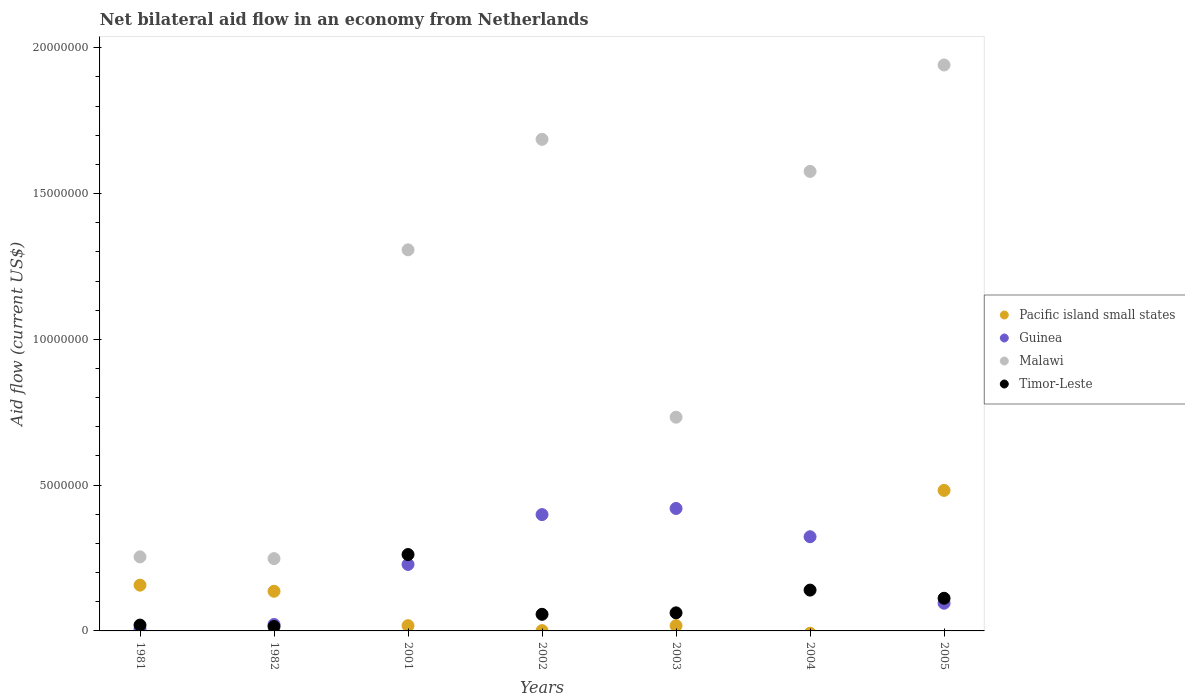How many different coloured dotlines are there?
Your response must be concise. 4. What is the net bilateral aid flow in Malawi in 2005?
Ensure brevity in your answer.  1.94e+07. Across all years, what is the maximum net bilateral aid flow in Timor-Leste?
Keep it short and to the point. 2.62e+06. What is the total net bilateral aid flow in Malawi in the graph?
Keep it short and to the point. 7.74e+07. What is the difference between the net bilateral aid flow in Timor-Leste in 1981 and that in 2004?
Give a very brief answer. -1.20e+06. What is the average net bilateral aid flow in Pacific island small states per year?
Make the answer very short. 1.16e+06. In the year 2003, what is the difference between the net bilateral aid flow in Malawi and net bilateral aid flow in Pacific island small states?
Your answer should be compact. 7.15e+06. What is the ratio of the net bilateral aid flow in Guinea in 1981 to that in 2005?
Your answer should be compact. 0.07. Is the net bilateral aid flow in Guinea in 2003 less than that in 2004?
Your answer should be very brief. No. What is the difference between the highest and the second highest net bilateral aid flow in Timor-Leste?
Provide a succinct answer. 1.22e+06. What is the difference between the highest and the lowest net bilateral aid flow in Pacific island small states?
Your answer should be compact. 4.82e+06. In how many years, is the net bilateral aid flow in Pacific island small states greater than the average net bilateral aid flow in Pacific island small states taken over all years?
Keep it short and to the point. 3. Is the sum of the net bilateral aid flow in Pacific island small states in 2001 and 2005 greater than the maximum net bilateral aid flow in Guinea across all years?
Provide a short and direct response. Yes. Does the net bilateral aid flow in Guinea monotonically increase over the years?
Give a very brief answer. No. Is the net bilateral aid flow in Malawi strictly greater than the net bilateral aid flow in Guinea over the years?
Make the answer very short. Yes. Is the net bilateral aid flow in Pacific island small states strictly less than the net bilateral aid flow in Malawi over the years?
Your answer should be very brief. Yes. How many years are there in the graph?
Offer a very short reply. 7. Are the values on the major ticks of Y-axis written in scientific E-notation?
Your answer should be compact. No. Does the graph contain grids?
Your answer should be compact. No. Where does the legend appear in the graph?
Offer a very short reply. Center right. What is the title of the graph?
Your answer should be very brief. Net bilateral aid flow in an economy from Netherlands. What is the Aid flow (current US$) in Pacific island small states in 1981?
Your response must be concise. 1.57e+06. What is the Aid flow (current US$) of Malawi in 1981?
Your answer should be compact. 2.54e+06. What is the Aid flow (current US$) of Timor-Leste in 1981?
Keep it short and to the point. 2.00e+05. What is the Aid flow (current US$) in Pacific island small states in 1982?
Offer a very short reply. 1.36e+06. What is the Aid flow (current US$) of Malawi in 1982?
Your answer should be compact. 2.48e+06. What is the Aid flow (current US$) in Timor-Leste in 1982?
Ensure brevity in your answer.  1.50e+05. What is the Aid flow (current US$) of Guinea in 2001?
Your response must be concise. 2.28e+06. What is the Aid flow (current US$) in Malawi in 2001?
Offer a very short reply. 1.31e+07. What is the Aid flow (current US$) in Timor-Leste in 2001?
Make the answer very short. 2.62e+06. What is the Aid flow (current US$) of Pacific island small states in 2002?
Your answer should be compact. 10000. What is the Aid flow (current US$) of Guinea in 2002?
Give a very brief answer. 3.99e+06. What is the Aid flow (current US$) in Malawi in 2002?
Give a very brief answer. 1.69e+07. What is the Aid flow (current US$) of Timor-Leste in 2002?
Offer a terse response. 5.70e+05. What is the Aid flow (current US$) of Pacific island small states in 2003?
Provide a short and direct response. 1.80e+05. What is the Aid flow (current US$) of Guinea in 2003?
Your response must be concise. 4.20e+06. What is the Aid flow (current US$) of Malawi in 2003?
Offer a very short reply. 7.33e+06. What is the Aid flow (current US$) of Timor-Leste in 2003?
Your answer should be very brief. 6.20e+05. What is the Aid flow (current US$) in Pacific island small states in 2004?
Keep it short and to the point. 0. What is the Aid flow (current US$) of Guinea in 2004?
Ensure brevity in your answer.  3.23e+06. What is the Aid flow (current US$) in Malawi in 2004?
Provide a short and direct response. 1.58e+07. What is the Aid flow (current US$) of Timor-Leste in 2004?
Keep it short and to the point. 1.40e+06. What is the Aid flow (current US$) in Pacific island small states in 2005?
Offer a very short reply. 4.82e+06. What is the Aid flow (current US$) of Guinea in 2005?
Your response must be concise. 9.50e+05. What is the Aid flow (current US$) in Malawi in 2005?
Ensure brevity in your answer.  1.94e+07. What is the Aid flow (current US$) in Timor-Leste in 2005?
Provide a short and direct response. 1.12e+06. Across all years, what is the maximum Aid flow (current US$) of Pacific island small states?
Offer a very short reply. 4.82e+06. Across all years, what is the maximum Aid flow (current US$) of Guinea?
Provide a succinct answer. 4.20e+06. Across all years, what is the maximum Aid flow (current US$) in Malawi?
Provide a succinct answer. 1.94e+07. Across all years, what is the maximum Aid flow (current US$) in Timor-Leste?
Make the answer very short. 2.62e+06. Across all years, what is the minimum Aid flow (current US$) of Pacific island small states?
Keep it short and to the point. 0. Across all years, what is the minimum Aid flow (current US$) in Malawi?
Your answer should be very brief. 2.48e+06. What is the total Aid flow (current US$) in Pacific island small states in the graph?
Your response must be concise. 8.12e+06. What is the total Aid flow (current US$) of Guinea in the graph?
Make the answer very short. 1.49e+07. What is the total Aid flow (current US$) of Malawi in the graph?
Provide a succinct answer. 7.74e+07. What is the total Aid flow (current US$) in Timor-Leste in the graph?
Make the answer very short. 6.68e+06. What is the difference between the Aid flow (current US$) in Pacific island small states in 1981 and that in 1982?
Your answer should be very brief. 2.10e+05. What is the difference between the Aid flow (current US$) of Guinea in 1981 and that in 1982?
Your answer should be very brief. -1.50e+05. What is the difference between the Aid flow (current US$) of Pacific island small states in 1981 and that in 2001?
Your answer should be very brief. 1.39e+06. What is the difference between the Aid flow (current US$) of Guinea in 1981 and that in 2001?
Provide a short and direct response. -2.21e+06. What is the difference between the Aid flow (current US$) in Malawi in 1981 and that in 2001?
Keep it short and to the point. -1.05e+07. What is the difference between the Aid flow (current US$) in Timor-Leste in 1981 and that in 2001?
Provide a succinct answer. -2.42e+06. What is the difference between the Aid flow (current US$) in Pacific island small states in 1981 and that in 2002?
Keep it short and to the point. 1.56e+06. What is the difference between the Aid flow (current US$) in Guinea in 1981 and that in 2002?
Give a very brief answer. -3.92e+06. What is the difference between the Aid flow (current US$) in Malawi in 1981 and that in 2002?
Give a very brief answer. -1.43e+07. What is the difference between the Aid flow (current US$) in Timor-Leste in 1981 and that in 2002?
Keep it short and to the point. -3.70e+05. What is the difference between the Aid flow (current US$) in Pacific island small states in 1981 and that in 2003?
Offer a very short reply. 1.39e+06. What is the difference between the Aid flow (current US$) in Guinea in 1981 and that in 2003?
Ensure brevity in your answer.  -4.13e+06. What is the difference between the Aid flow (current US$) of Malawi in 1981 and that in 2003?
Give a very brief answer. -4.79e+06. What is the difference between the Aid flow (current US$) of Timor-Leste in 1981 and that in 2003?
Keep it short and to the point. -4.20e+05. What is the difference between the Aid flow (current US$) in Guinea in 1981 and that in 2004?
Offer a terse response. -3.16e+06. What is the difference between the Aid flow (current US$) in Malawi in 1981 and that in 2004?
Make the answer very short. -1.32e+07. What is the difference between the Aid flow (current US$) of Timor-Leste in 1981 and that in 2004?
Offer a very short reply. -1.20e+06. What is the difference between the Aid flow (current US$) in Pacific island small states in 1981 and that in 2005?
Provide a short and direct response. -3.25e+06. What is the difference between the Aid flow (current US$) of Guinea in 1981 and that in 2005?
Offer a very short reply. -8.80e+05. What is the difference between the Aid flow (current US$) of Malawi in 1981 and that in 2005?
Ensure brevity in your answer.  -1.69e+07. What is the difference between the Aid flow (current US$) in Timor-Leste in 1981 and that in 2005?
Provide a short and direct response. -9.20e+05. What is the difference between the Aid flow (current US$) of Pacific island small states in 1982 and that in 2001?
Your answer should be very brief. 1.18e+06. What is the difference between the Aid flow (current US$) of Guinea in 1982 and that in 2001?
Provide a short and direct response. -2.06e+06. What is the difference between the Aid flow (current US$) in Malawi in 1982 and that in 2001?
Your answer should be compact. -1.06e+07. What is the difference between the Aid flow (current US$) in Timor-Leste in 1982 and that in 2001?
Provide a succinct answer. -2.47e+06. What is the difference between the Aid flow (current US$) of Pacific island small states in 1982 and that in 2002?
Give a very brief answer. 1.35e+06. What is the difference between the Aid flow (current US$) in Guinea in 1982 and that in 2002?
Your answer should be compact. -3.77e+06. What is the difference between the Aid flow (current US$) of Malawi in 1982 and that in 2002?
Your response must be concise. -1.44e+07. What is the difference between the Aid flow (current US$) of Timor-Leste in 1982 and that in 2002?
Provide a short and direct response. -4.20e+05. What is the difference between the Aid flow (current US$) in Pacific island small states in 1982 and that in 2003?
Provide a succinct answer. 1.18e+06. What is the difference between the Aid flow (current US$) in Guinea in 1982 and that in 2003?
Offer a very short reply. -3.98e+06. What is the difference between the Aid flow (current US$) of Malawi in 1982 and that in 2003?
Keep it short and to the point. -4.85e+06. What is the difference between the Aid flow (current US$) in Timor-Leste in 1982 and that in 2003?
Ensure brevity in your answer.  -4.70e+05. What is the difference between the Aid flow (current US$) in Guinea in 1982 and that in 2004?
Offer a very short reply. -3.01e+06. What is the difference between the Aid flow (current US$) of Malawi in 1982 and that in 2004?
Keep it short and to the point. -1.33e+07. What is the difference between the Aid flow (current US$) in Timor-Leste in 1982 and that in 2004?
Ensure brevity in your answer.  -1.25e+06. What is the difference between the Aid flow (current US$) in Pacific island small states in 1982 and that in 2005?
Make the answer very short. -3.46e+06. What is the difference between the Aid flow (current US$) in Guinea in 1982 and that in 2005?
Offer a very short reply. -7.30e+05. What is the difference between the Aid flow (current US$) in Malawi in 1982 and that in 2005?
Provide a short and direct response. -1.69e+07. What is the difference between the Aid flow (current US$) in Timor-Leste in 1982 and that in 2005?
Provide a succinct answer. -9.70e+05. What is the difference between the Aid flow (current US$) in Guinea in 2001 and that in 2002?
Your answer should be compact. -1.71e+06. What is the difference between the Aid flow (current US$) of Malawi in 2001 and that in 2002?
Your answer should be very brief. -3.79e+06. What is the difference between the Aid flow (current US$) in Timor-Leste in 2001 and that in 2002?
Your answer should be compact. 2.05e+06. What is the difference between the Aid flow (current US$) of Guinea in 2001 and that in 2003?
Your answer should be very brief. -1.92e+06. What is the difference between the Aid flow (current US$) in Malawi in 2001 and that in 2003?
Your response must be concise. 5.74e+06. What is the difference between the Aid flow (current US$) of Timor-Leste in 2001 and that in 2003?
Offer a terse response. 2.00e+06. What is the difference between the Aid flow (current US$) of Guinea in 2001 and that in 2004?
Keep it short and to the point. -9.50e+05. What is the difference between the Aid flow (current US$) of Malawi in 2001 and that in 2004?
Your answer should be very brief. -2.69e+06. What is the difference between the Aid flow (current US$) of Timor-Leste in 2001 and that in 2004?
Ensure brevity in your answer.  1.22e+06. What is the difference between the Aid flow (current US$) in Pacific island small states in 2001 and that in 2005?
Make the answer very short. -4.64e+06. What is the difference between the Aid flow (current US$) in Guinea in 2001 and that in 2005?
Offer a terse response. 1.33e+06. What is the difference between the Aid flow (current US$) in Malawi in 2001 and that in 2005?
Keep it short and to the point. -6.34e+06. What is the difference between the Aid flow (current US$) in Timor-Leste in 2001 and that in 2005?
Give a very brief answer. 1.50e+06. What is the difference between the Aid flow (current US$) in Pacific island small states in 2002 and that in 2003?
Offer a terse response. -1.70e+05. What is the difference between the Aid flow (current US$) of Malawi in 2002 and that in 2003?
Offer a terse response. 9.53e+06. What is the difference between the Aid flow (current US$) in Timor-Leste in 2002 and that in 2003?
Provide a succinct answer. -5.00e+04. What is the difference between the Aid flow (current US$) of Guinea in 2002 and that in 2004?
Ensure brevity in your answer.  7.60e+05. What is the difference between the Aid flow (current US$) in Malawi in 2002 and that in 2004?
Your answer should be very brief. 1.10e+06. What is the difference between the Aid flow (current US$) in Timor-Leste in 2002 and that in 2004?
Provide a short and direct response. -8.30e+05. What is the difference between the Aid flow (current US$) of Pacific island small states in 2002 and that in 2005?
Keep it short and to the point. -4.81e+06. What is the difference between the Aid flow (current US$) of Guinea in 2002 and that in 2005?
Your response must be concise. 3.04e+06. What is the difference between the Aid flow (current US$) in Malawi in 2002 and that in 2005?
Give a very brief answer. -2.55e+06. What is the difference between the Aid flow (current US$) in Timor-Leste in 2002 and that in 2005?
Your answer should be compact. -5.50e+05. What is the difference between the Aid flow (current US$) of Guinea in 2003 and that in 2004?
Offer a very short reply. 9.70e+05. What is the difference between the Aid flow (current US$) of Malawi in 2003 and that in 2004?
Provide a succinct answer. -8.43e+06. What is the difference between the Aid flow (current US$) of Timor-Leste in 2003 and that in 2004?
Offer a very short reply. -7.80e+05. What is the difference between the Aid flow (current US$) in Pacific island small states in 2003 and that in 2005?
Offer a very short reply. -4.64e+06. What is the difference between the Aid flow (current US$) of Guinea in 2003 and that in 2005?
Offer a very short reply. 3.25e+06. What is the difference between the Aid flow (current US$) of Malawi in 2003 and that in 2005?
Provide a succinct answer. -1.21e+07. What is the difference between the Aid flow (current US$) of Timor-Leste in 2003 and that in 2005?
Provide a short and direct response. -5.00e+05. What is the difference between the Aid flow (current US$) of Guinea in 2004 and that in 2005?
Make the answer very short. 2.28e+06. What is the difference between the Aid flow (current US$) of Malawi in 2004 and that in 2005?
Provide a succinct answer. -3.65e+06. What is the difference between the Aid flow (current US$) of Timor-Leste in 2004 and that in 2005?
Ensure brevity in your answer.  2.80e+05. What is the difference between the Aid flow (current US$) in Pacific island small states in 1981 and the Aid flow (current US$) in Guinea in 1982?
Offer a terse response. 1.35e+06. What is the difference between the Aid flow (current US$) in Pacific island small states in 1981 and the Aid flow (current US$) in Malawi in 1982?
Your answer should be very brief. -9.10e+05. What is the difference between the Aid flow (current US$) of Pacific island small states in 1981 and the Aid flow (current US$) of Timor-Leste in 1982?
Make the answer very short. 1.42e+06. What is the difference between the Aid flow (current US$) in Guinea in 1981 and the Aid flow (current US$) in Malawi in 1982?
Provide a succinct answer. -2.41e+06. What is the difference between the Aid flow (current US$) in Malawi in 1981 and the Aid flow (current US$) in Timor-Leste in 1982?
Offer a terse response. 2.39e+06. What is the difference between the Aid flow (current US$) in Pacific island small states in 1981 and the Aid flow (current US$) in Guinea in 2001?
Provide a short and direct response. -7.10e+05. What is the difference between the Aid flow (current US$) in Pacific island small states in 1981 and the Aid flow (current US$) in Malawi in 2001?
Provide a short and direct response. -1.15e+07. What is the difference between the Aid flow (current US$) of Pacific island small states in 1981 and the Aid flow (current US$) of Timor-Leste in 2001?
Ensure brevity in your answer.  -1.05e+06. What is the difference between the Aid flow (current US$) in Guinea in 1981 and the Aid flow (current US$) in Malawi in 2001?
Your response must be concise. -1.30e+07. What is the difference between the Aid flow (current US$) of Guinea in 1981 and the Aid flow (current US$) of Timor-Leste in 2001?
Your answer should be very brief. -2.55e+06. What is the difference between the Aid flow (current US$) of Malawi in 1981 and the Aid flow (current US$) of Timor-Leste in 2001?
Ensure brevity in your answer.  -8.00e+04. What is the difference between the Aid flow (current US$) in Pacific island small states in 1981 and the Aid flow (current US$) in Guinea in 2002?
Provide a succinct answer. -2.42e+06. What is the difference between the Aid flow (current US$) of Pacific island small states in 1981 and the Aid flow (current US$) of Malawi in 2002?
Make the answer very short. -1.53e+07. What is the difference between the Aid flow (current US$) in Pacific island small states in 1981 and the Aid flow (current US$) in Timor-Leste in 2002?
Your answer should be very brief. 1.00e+06. What is the difference between the Aid flow (current US$) of Guinea in 1981 and the Aid flow (current US$) of Malawi in 2002?
Your response must be concise. -1.68e+07. What is the difference between the Aid flow (current US$) in Guinea in 1981 and the Aid flow (current US$) in Timor-Leste in 2002?
Give a very brief answer. -5.00e+05. What is the difference between the Aid flow (current US$) of Malawi in 1981 and the Aid flow (current US$) of Timor-Leste in 2002?
Your answer should be compact. 1.97e+06. What is the difference between the Aid flow (current US$) of Pacific island small states in 1981 and the Aid flow (current US$) of Guinea in 2003?
Provide a short and direct response. -2.63e+06. What is the difference between the Aid flow (current US$) in Pacific island small states in 1981 and the Aid flow (current US$) in Malawi in 2003?
Provide a short and direct response. -5.76e+06. What is the difference between the Aid flow (current US$) in Pacific island small states in 1981 and the Aid flow (current US$) in Timor-Leste in 2003?
Ensure brevity in your answer.  9.50e+05. What is the difference between the Aid flow (current US$) of Guinea in 1981 and the Aid flow (current US$) of Malawi in 2003?
Offer a terse response. -7.26e+06. What is the difference between the Aid flow (current US$) of Guinea in 1981 and the Aid flow (current US$) of Timor-Leste in 2003?
Provide a succinct answer. -5.50e+05. What is the difference between the Aid flow (current US$) of Malawi in 1981 and the Aid flow (current US$) of Timor-Leste in 2003?
Your answer should be compact. 1.92e+06. What is the difference between the Aid flow (current US$) of Pacific island small states in 1981 and the Aid flow (current US$) of Guinea in 2004?
Your response must be concise. -1.66e+06. What is the difference between the Aid flow (current US$) in Pacific island small states in 1981 and the Aid flow (current US$) in Malawi in 2004?
Your answer should be compact. -1.42e+07. What is the difference between the Aid flow (current US$) in Pacific island small states in 1981 and the Aid flow (current US$) in Timor-Leste in 2004?
Provide a succinct answer. 1.70e+05. What is the difference between the Aid flow (current US$) of Guinea in 1981 and the Aid flow (current US$) of Malawi in 2004?
Ensure brevity in your answer.  -1.57e+07. What is the difference between the Aid flow (current US$) of Guinea in 1981 and the Aid flow (current US$) of Timor-Leste in 2004?
Keep it short and to the point. -1.33e+06. What is the difference between the Aid flow (current US$) in Malawi in 1981 and the Aid flow (current US$) in Timor-Leste in 2004?
Your response must be concise. 1.14e+06. What is the difference between the Aid flow (current US$) in Pacific island small states in 1981 and the Aid flow (current US$) in Guinea in 2005?
Keep it short and to the point. 6.20e+05. What is the difference between the Aid flow (current US$) in Pacific island small states in 1981 and the Aid flow (current US$) in Malawi in 2005?
Your response must be concise. -1.78e+07. What is the difference between the Aid flow (current US$) in Guinea in 1981 and the Aid flow (current US$) in Malawi in 2005?
Ensure brevity in your answer.  -1.93e+07. What is the difference between the Aid flow (current US$) in Guinea in 1981 and the Aid flow (current US$) in Timor-Leste in 2005?
Your answer should be very brief. -1.05e+06. What is the difference between the Aid flow (current US$) in Malawi in 1981 and the Aid flow (current US$) in Timor-Leste in 2005?
Keep it short and to the point. 1.42e+06. What is the difference between the Aid flow (current US$) of Pacific island small states in 1982 and the Aid flow (current US$) of Guinea in 2001?
Keep it short and to the point. -9.20e+05. What is the difference between the Aid flow (current US$) of Pacific island small states in 1982 and the Aid flow (current US$) of Malawi in 2001?
Offer a terse response. -1.17e+07. What is the difference between the Aid flow (current US$) of Pacific island small states in 1982 and the Aid flow (current US$) of Timor-Leste in 2001?
Keep it short and to the point. -1.26e+06. What is the difference between the Aid flow (current US$) of Guinea in 1982 and the Aid flow (current US$) of Malawi in 2001?
Offer a terse response. -1.28e+07. What is the difference between the Aid flow (current US$) of Guinea in 1982 and the Aid flow (current US$) of Timor-Leste in 2001?
Offer a terse response. -2.40e+06. What is the difference between the Aid flow (current US$) of Pacific island small states in 1982 and the Aid flow (current US$) of Guinea in 2002?
Keep it short and to the point. -2.63e+06. What is the difference between the Aid flow (current US$) of Pacific island small states in 1982 and the Aid flow (current US$) of Malawi in 2002?
Give a very brief answer. -1.55e+07. What is the difference between the Aid flow (current US$) in Pacific island small states in 1982 and the Aid flow (current US$) in Timor-Leste in 2002?
Your response must be concise. 7.90e+05. What is the difference between the Aid flow (current US$) in Guinea in 1982 and the Aid flow (current US$) in Malawi in 2002?
Ensure brevity in your answer.  -1.66e+07. What is the difference between the Aid flow (current US$) in Guinea in 1982 and the Aid flow (current US$) in Timor-Leste in 2002?
Offer a terse response. -3.50e+05. What is the difference between the Aid flow (current US$) of Malawi in 1982 and the Aid flow (current US$) of Timor-Leste in 2002?
Provide a succinct answer. 1.91e+06. What is the difference between the Aid flow (current US$) of Pacific island small states in 1982 and the Aid flow (current US$) of Guinea in 2003?
Your answer should be very brief. -2.84e+06. What is the difference between the Aid flow (current US$) of Pacific island small states in 1982 and the Aid flow (current US$) of Malawi in 2003?
Offer a terse response. -5.97e+06. What is the difference between the Aid flow (current US$) in Pacific island small states in 1982 and the Aid flow (current US$) in Timor-Leste in 2003?
Make the answer very short. 7.40e+05. What is the difference between the Aid flow (current US$) of Guinea in 1982 and the Aid flow (current US$) of Malawi in 2003?
Keep it short and to the point. -7.11e+06. What is the difference between the Aid flow (current US$) of Guinea in 1982 and the Aid flow (current US$) of Timor-Leste in 2003?
Offer a very short reply. -4.00e+05. What is the difference between the Aid flow (current US$) of Malawi in 1982 and the Aid flow (current US$) of Timor-Leste in 2003?
Your answer should be compact. 1.86e+06. What is the difference between the Aid flow (current US$) in Pacific island small states in 1982 and the Aid flow (current US$) in Guinea in 2004?
Provide a succinct answer. -1.87e+06. What is the difference between the Aid flow (current US$) of Pacific island small states in 1982 and the Aid flow (current US$) of Malawi in 2004?
Keep it short and to the point. -1.44e+07. What is the difference between the Aid flow (current US$) of Pacific island small states in 1982 and the Aid flow (current US$) of Timor-Leste in 2004?
Provide a short and direct response. -4.00e+04. What is the difference between the Aid flow (current US$) of Guinea in 1982 and the Aid flow (current US$) of Malawi in 2004?
Provide a succinct answer. -1.55e+07. What is the difference between the Aid flow (current US$) of Guinea in 1982 and the Aid flow (current US$) of Timor-Leste in 2004?
Give a very brief answer. -1.18e+06. What is the difference between the Aid flow (current US$) in Malawi in 1982 and the Aid flow (current US$) in Timor-Leste in 2004?
Your response must be concise. 1.08e+06. What is the difference between the Aid flow (current US$) of Pacific island small states in 1982 and the Aid flow (current US$) of Malawi in 2005?
Provide a succinct answer. -1.80e+07. What is the difference between the Aid flow (current US$) of Pacific island small states in 1982 and the Aid flow (current US$) of Timor-Leste in 2005?
Offer a terse response. 2.40e+05. What is the difference between the Aid flow (current US$) of Guinea in 1982 and the Aid flow (current US$) of Malawi in 2005?
Provide a succinct answer. -1.92e+07. What is the difference between the Aid flow (current US$) in Guinea in 1982 and the Aid flow (current US$) in Timor-Leste in 2005?
Keep it short and to the point. -9.00e+05. What is the difference between the Aid flow (current US$) in Malawi in 1982 and the Aid flow (current US$) in Timor-Leste in 2005?
Keep it short and to the point. 1.36e+06. What is the difference between the Aid flow (current US$) of Pacific island small states in 2001 and the Aid flow (current US$) of Guinea in 2002?
Your response must be concise. -3.81e+06. What is the difference between the Aid flow (current US$) in Pacific island small states in 2001 and the Aid flow (current US$) in Malawi in 2002?
Your response must be concise. -1.67e+07. What is the difference between the Aid flow (current US$) of Pacific island small states in 2001 and the Aid flow (current US$) of Timor-Leste in 2002?
Provide a short and direct response. -3.90e+05. What is the difference between the Aid flow (current US$) in Guinea in 2001 and the Aid flow (current US$) in Malawi in 2002?
Keep it short and to the point. -1.46e+07. What is the difference between the Aid flow (current US$) of Guinea in 2001 and the Aid flow (current US$) of Timor-Leste in 2002?
Your answer should be very brief. 1.71e+06. What is the difference between the Aid flow (current US$) of Malawi in 2001 and the Aid flow (current US$) of Timor-Leste in 2002?
Your answer should be very brief. 1.25e+07. What is the difference between the Aid flow (current US$) in Pacific island small states in 2001 and the Aid flow (current US$) in Guinea in 2003?
Your response must be concise. -4.02e+06. What is the difference between the Aid flow (current US$) in Pacific island small states in 2001 and the Aid flow (current US$) in Malawi in 2003?
Offer a very short reply. -7.15e+06. What is the difference between the Aid flow (current US$) of Pacific island small states in 2001 and the Aid flow (current US$) of Timor-Leste in 2003?
Offer a terse response. -4.40e+05. What is the difference between the Aid flow (current US$) of Guinea in 2001 and the Aid flow (current US$) of Malawi in 2003?
Your response must be concise. -5.05e+06. What is the difference between the Aid flow (current US$) of Guinea in 2001 and the Aid flow (current US$) of Timor-Leste in 2003?
Keep it short and to the point. 1.66e+06. What is the difference between the Aid flow (current US$) in Malawi in 2001 and the Aid flow (current US$) in Timor-Leste in 2003?
Keep it short and to the point. 1.24e+07. What is the difference between the Aid flow (current US$) of Pacific island small states in 2001 and the Aid flow (current US$) of Guinea in 2004?
Keep it short and to the point. -3.05e+06. What is the difference between the Aid flow (current US$) in Pacific island small states in 2001 and the Aid flow (current US$) in Malawi in 2004?
Make the answer very short. -1.56e+07. What is the difference between the Aid flow (current US$) in Pacific island small states in 2001 and the Aid flow (current US$) in Timor-Leste in 2004?
Your response must be concise. -1.22e+06. What is the difference between the Aid flow (current US$) of Guinea in 2001 and the Aid flow (current US$) of Malawi in 2004?
Offer a very short reply. -1.35e+07. What is the difference between the Aid flow (current US$) of Guinea in 2001 and the Aid flow (current US$) of Timor-Leste in 2004?
Your answer should be compact. 8.80e+05. What is the difference between the Aid flow (current US$) of Malawi in 2001 and the Aid flow (current US$) of Timor-Leste in 2004?
Make the answer very short. 1.17e+07. What is the difference between the Aid flow (current US$) of Pacific island small states in 2001 and the Aid flow (current US$) of Guinea in 2005?
Provide a succinct answer. -7.70e+05. What is the difference between the Aid flow (current US$) in Pacific island small states in 2001 and the Aid flow (current US$) in Malawi in 2005?
Provide a short and direct response. -1.92e+07. What is the difference between the Aid flow (current US$) in Pacific island small states in 2001 and the Aid flow (current US$) in Timor-Leste in 2005?
Keep it short and to the point. -9.40e+05. What is the difference between the Aid flow (current US$) in Guinea in 2001 and the Aid flow (current US$) in Malawi in 2005?
Offer a terse response. -1.71e+07. What is the difference between the Aid flow (current US$) of Guinea in 2001 and the Aid flow (current US$) of Timor-Leste in 2005?
Offer a terse response. 1.16e+06. What is the difference between the Aid flow (current US$) of Malawi in 2001 and the Aid flow (current US$) of Timor-Leste in 2005?
Offer a very short reply. 1.20e+07. What is the difference between the Aid flow (current US$) in Pacific island small states in 2002 and the Aid flow (current US$) in Guinea in 2003?
Give a very brief answer. -4.19e+06. What is the difference between the Aid flow (current US$) of Pacific island small states in 2002 and the Aid flow (current US$) of Malawi in 2003?
Your answer should be compact. -7.32e+06. What is the difference between the Aid flow (current US$) of Pacific island small states in 2002 and the Aid flow (current US$) of Timor-Leste in 2003?
Offer a terse response. -6.10e+05. What is the difference between the Aid flow (current US$) of Guinea in 2002 and the Aid flow (current US$) of Malawi in 2003?
Make the answer very short. -3.34e+06. What is the difference between the Aid flow (current US$) of Guinea in 2002 and the Aid flow (current US$) of Timor-Leste in 2003?
Offer a very short reply. 3.37e+06. What is the difference between the Aid flow (current US$) in Malawi in 2002 and the Aid flow (current US$) in Timor-Leste in 2003?
Provide a short and direct response. 1.62e+07. What is the difference between the Aid flow (current US$) in Pacific island small states in 2002 and the Aid flow (current US$) in Guinea in 2004?
Ensure brevity in your answer.  -3.22e+06. What is the difference between the Aid flow (current US$) in Pacific island small states in 2002 and the Aid flow (current US$) in Malawi in 2004?
Give a very brief answer. -1.58e+07. What is the difference between the Aid flow (current US$) of Pacific island small states in 2002 and the Aid flow (current US$) of Timor-Leste in 2004?
Offer a very short reply. -1.39e+06. What is the difference between the Aid flow (current US$) of Guinea in 2002 and the Aid flow (current US$) of Malawi in 2004?
Provide a short and direct response. -1.18e+07. What is the difference between the Aid flow (current US$) in Guinea in 2002 and the Aid flow (current US$) in Timor-Leste in 2004?
Your answer should be very brief. 2.59e+06. What is the difference between the Aid flow (current US$) of Malawi in 2002 and the Aid flow (current US$) of Timor-Leste in 2004?
Provide a short and direct response. 1.55e+07. What is the difference between the Aid flow (current US$) in Pacific island small states in 2002 and the Aid flow (current US$) in Guinea in 2005?
Offer a terse response. -9.40e+05. What is the difference between the Aid flow (current US$) in Pacific island small states in 2002 and the Aid flow (current US$) in Malawi in 2005?
Give a very brief answer. -1.94e+07. What is the difference between the Aid flow (current US$) in Pacific island small states in 2002 and the Aid flow (current US$) in Timor-Leste in 2005?
Your answer should be compact. -1.11e+06. What is the difference between the Aid flow (current US$) in Guinea in 2002 and the Aid flow (current US$) in Malawi in 2005?
Offer a terse response. -1.54e+07. What is the difference between the Aid flow (current US$) in Guinea in 2002 and the Aid flow (current US$) in Timor-Leste in 2005?
Provide a short and direct response. 2.87e+06. What is the difference between the Aid flow (current US$) of Malawi in 2002 and the Aid flow (current US$) of Timor-Leste in 2005?
Give a very brief answer. 1.57e+07. What is the difference between the Aid flow (current US$) of Pacific island small states in 2003 and the Aid flow (current US$) of Guinea in 2004?
Your response must be concise. -3.05e+06. What is the difference between the Aid flow (current US$) in Pacific island small states in 2003 and the Aid flow (current US$) in Malawi in 2004?
Ensure brevity in your answer.  -1.56e+07. What is the difference between the Aid flow (current US$) of Pacific island small states in 2003 and the Aid flow (current US$) of Timor-Leste in 2004?
Offer a very short reply. -1.22e+06. What is the difference between the Aid flow (current US$) of Guinea in 2003 and the Aid flow (current US$) of Malawi in 2004?
Offer a terse response. -1.16e+07. What is the difference between the Aid flow (current US$) of Guinea in 2003 and the Aid flow (current US$) of Timor-Leste in 2004?
Give a very brief answer. 2.80e+06. What is the difference between the Aid flow (current US$) of Malawi in 2003 and the Aid flow (current US$) of Timor-Leste in 2004?
Your answer should be compact. 5.93e+06. What is the difference between the Aid flow (current US$) in Pacific island small states in 2003 and the Aid flow (current US$) in Guinea in 2005?
Ensure brevity in your answer.  -7.70e+05. What is the difference between the Aid flow (current US$) of Pacific island small states in 2003 and the Aid flow (current US$) of Malawi in 2005?
Your answer should be very brief. -1.92e+07. What is the difference between the Aid flow (current US$) in Pacific island small states in 2003 and the Aid flow (current US$) in Timor-Leste in 2005?
Offer a terse response. -9.40e+05. What is the difference between the Aid flow (current US$) in Guinea in 2003 and the Aid flow (current US$) in Malawi in 2005?
Make the answer very short. -1.52e+07. What is the difference between the Aid flow (current US$) in Guinea in 2003 and the Aid flow (current US$) in Timor-Leste in 2005?
Your answer should be very brief. 3.08e+06. What is the difference between the Aid flow (current US$) in Malawi in 2003 and the Aid flow (current US$) in Timor-Leste in 2005?
Keep it short and to the point. 6.21e+06. What is the difference between the Aid flow (current US$) of Guinea in 2004 and the Aid flow (current US$) of Malawi in 2005?
Your answer should be compact. -1.62e+07. What is the difference between the Aid flow (current US$) in Guinea in 2004 and the Aid flow (current US$) in Timor-Leste in 2005?
Provide a succinct answer. 2.11e+06. What is the difference between the Aid flow (current US$) of Malawi in 2004 and the Aid flow (current US$) of Timor-Leste in 2005?
Keep it short and to the point. 1.46e+07. What is the average Aid flow (current US$) in Pacific island small states per year?
Keep it short and to the point. 1.16e+06. What is the average Aid flow (current US$) of Guinea per year?
Provide a short and direct response. 2.13e+06. What is the average Aid flow (current US$) in Malawi per year?
Your answer should be compact. 1.11e+07. What is the average Aid flow (current US$) of Timor-Leste per year?
Provide a short and direct response. 9.54e+05. In the year 1981, what is the difference between the Aid flow (current US$) in Pacific island small states and Aid flow (current US$) in Guinea?
Your response must be concise. 1.50e+06. In the year 1981, what is the difference between the Aid flow (current US$) of Pacific island small states and Aid flow (current US$) of Malawi?
Make the answer very short. -9.70e+05. In the year 1981, what is the difference between the Aid flow (current US$) of Pacific island small states and Aid flow (current US$) of Timor-Leste?
Provide a short and direct response. 1.37e+06. In the year 1981, what is the difference between the Aid flow (current US$) in Guinea and Aid flow (current US$) in Malawi?
Your response must be concise. -2.47e+06. In the year 1981, what is the difference between the Aid flow (current US$) of Guinea and Aid flow (current US$) of Timor-Leste?
Make the answer very short. -1.30e+05. In the year 1981, what is the difference between the Aid flow (current US$) in Malawi and Aid flow (current US$) in Timor-Leste?
Your answer should be very brief. 2.34e+06. In the year 1982, what is the difference between the Aid flow (current US$) of Pacific island small states and Aid flow (current US$) of Guinea?
Make the answer very short. 1.14e+06. In the year 1982, what is the difference between the Aid flow (current US$) of Pacific island small states and Aid flow (current US$) of Malawi?
Offer a terse response. -1.12e+06. In the year 1982, what is the difference between the Aid flow (current US$) of Pacific island small states and Aid flow (current US$) of Timor-Leste?
Offer a terse response. 1.21e+06. In the year 1982, what is the difference between the Aid flow (current US$) of Guinea and Aid flow (current US$) of Malawi?
Your response must be concise. -2.26e+06. In the year 1982, what is the difference between the Aid flow (current US$) in Malawi and Aid flow (current US$) in Timor-Leste?
Your answer should be compact. 2.33e+06. In the year 2001, what is the difference between the Aid flow (current US$) of Pacific island small states and Aid flow (current US$) of Guinea?
Provide a short and direct response. -2.10e+06. In the year 2001, what is the difference between the Aid flow (current US$) of Pacific island small states and Aid flow (current US$) of Malawi?
Offer a terse response. -1.29e+07. In the year 2001, what is the difference between the Aid flow (current US$) in Pacific island small states and Aid flow (current US$) in Timor-Leste?
Provide a short and direct response. -2.44e+06. In the year 2001, what is the difference between the Aid flow (current US$) of Guinea and Aid flow (current US$) of Malawi?
Provide a short and direct response. -1.08e+07. In the year 2001, what is the difference between the Aid flow (current US$) in Malawi and Aid flow (current US$) in Timor-Leste?
Give a very brief answer. 1.04e+07. In the year 2002, what is the difference between the Aid flow (current US$) in Pacific island small states and Aid flow (current US$) in Guinea?
Provide a succinct answer. -3.98e+06. In the year 2002, what is the difference between the Aid flow (current US$) in Pacific island small states and Aid flow (current US$) in Malawi?
Provide a succinct answer. -1.68e+07. In the year 2002, what is the difference between the Aid flow (current US$) of Pacific island small states and Aid flow (current US$) of Timor-Leste?
Ensure brevity in your answer.  -5.60e+05. In the year 2002, what is the difference between the Aid flow (current US$) in Guinea and Aid flow (current US$) in Malawi?
Make the answer very short. -1.29e+07. In the year 2002, what is the difference between the Aid flow (current US$) of Guinea and Aid flow (current US$) of Timor-Leste?
Your answer should be compact. 3.42e+06. In the year 2002, what is the difference between the Aid flow (current US$) of Malawi and Aid flow (current US$) of Timor-Leste?
Provide a succinct answer. 1.63e+07. In the year 2003, what is the difference between the Aid flow (current US$) in Pacific island small states and Aid flow (current US$) in Guinea?
Your answer should be compact. -4.02e+06. In the year 2003, what is the difference between the Aid flow (current US$) of Pacific island small states and Aid flow (current US$) of Malawi?
Offer a very short reply. -7.15e+06. In the year 2003, what is the difference between the Aid flow (current US$) of Pacific island small states and Aid flow (current US$) of Timor-Leste?
Make the answer very short. -4.40e+05. In the year 2003, what is the difference between the Aid flow (current US$) of Guinea and Aid flow (current US$) of Malawi?
Your answer should be very brief. -3.13e+06. In the year 2003, what is the difference between the Aid flow (current US$) of Guinea and Aid flow (current US$) of Timor-Leste?
Give a very brief answer. 3.58e+06. In the year 2003, what is the difference between the Aid flow (current US$) of Malawi and Aid flow (current US$) of Timor-Leste?
Offer a terse response. 6.71e+06. In the year 2004, what is the difference between the Aid flow (current US$) in Guinea and Aid flow (current US$) in Malawi?
Ensure brevity in your answer.  -1.25e+07. In the year 2004, what is the difference between the Aid flow (current US$) in Guinea and Aid flow (current US$) in Timor-Leste?
Give a very brief answer. 1.83e+06. In the year 2004, what is the difference between the Aid flow (current US$) in Malawi and Aid flow (current US$) in Timor-Leste?
Your response must be concise. 1.44e+07. In the year 2005, what is the difference between the Aid flow (current US$) of Pacific island small states and Aid flow (current US$) of Guinea?
Provide a short and direct response. 3.87e+06. In the year 2005, what is the difference between the Aid flow (current US$) of Pacific island small states and Aid flow (current US$) of Malawi?
Provide a short and direct response. -1.46e+07. In the year 2005, what is the difference between the Aid flow (current US$) of Pacific island small states and Aid flow (current US$) of Timor-Leste?
Offer a terse response. 3.70e+06. In the year 2005, what is the difference between the Aid flow (current US$) in Guinea and Aid flow (current US$) in Malawi?
Offer a terse response. -1.85e+07. In the year 2005, what is the difference between the Aid flow (current US$) in Malawi and Aid flow (current US$) in Timor-Leste?
Your response must be concise. 1.83e+07. What is the ratio of the Aid flow (current US$) in Pacific island small states in 1981 to that in 1982?
Keep it short and to the point. 1.15. What is the ratio of the Aid flow (current US$) of Guinea in 1981 to that in 1982?
Your answer should be compact. 0.32. What is the ratio of the Aid flow (current US$) of Malawi in 1981 to that in 1982?
Your answer should be very brief. 1.02. What is the ratio of the Aid flow (current US$) of Pacific island small states in 1981 to that in 2001?
Make the answer very short. 8.72. What is the ratio of the Aid flow (current US$) of Guinea in 1981 to that in 2001?
Your response must be concise. 0.03. What is the ratio of the Aid flow (current US$) in Malawi in 1981 to that in 2001?
Ensure brevity in your answer.  0.19. What is the ratio of the Aid flow (current US$) in Timor-Leste in 1981 to that in 2001?
Your answer should be compact. 0.08. What is the ratio of the Aid flow (current US$) in Pacific island small states in 1981 to that in 2002?
Provide a short and direct response. 157. What is the ratio of the Aid flow (current US$) in Guinea in 1981 to that in 2002?
Keep it short and to the point. 0.02. What is the ratio of the Aid flow (current US$) of Malawi in 1981 to that in 2002?
Make the answer very short. 0.15. What is the ratio of the Aid flow (current US$) of Timor-Leste in 1981 to that in 2002?
Ensure brevity in your answer.  0.35. What is the ratio of the Aid flow (current US$) in Pacific island small states in 1981 to that in 2003?
Provide a succinct answer. 8.72. What is the ratio of the Aid flow (current US$) in Guinea in 1981 to that in 2003?
Give a very brief answer. 0.02. What is the ratio of the Aid flow (current US$) of Malawi in 1981 to that in 2003?
Ensure brevity in your answer.  0.35. What is the ratio of the Aid flow (current US$) of Timor-Leste in 1981 to that in 2003?
Offer a terse response. 0.32. What is the ratio of the Aid flow (current US$) in Guinea in 1981 to that in 2004?
Ensure brevity in your answer.  0.02. What is the ratio of the Aid flow (current US$) of Malawi in 1981 to that in 2004?
Give a very brief answer. 0.16. What is the ratio of the Aid flow (current US$) in Timor-Leste in 1981 to that in 2004?
Keep it short and to the point. 0.14. What is the ratio of the Aid flow (current US$) in Pacific island small states in 1981 to that in 2005?
Offer a terse response. 0.33. What is the ratio of the Aid flow (current US$) of Guinea in 1981 to that in 2005?
Offer a very short reply. 0.07. What is the ratio of the Aid flow (current US$) of Malawi in 1981 to that in 2005?
Your response must be concise. 0.13. What is the ratio of the Aid flow (current US$) of Timor-Leste in 1981 to that in 2005?
Your answer should be very brief. 0.18. What is the ratio of the Aid flow (current US$) in Pacific island small states in 1982 to that in 2001?
Provide a succinct answer. 7.56. What is the ratio of the Aid flow (current US$) of Guinea in 1982 to that in 2001?
Make the answer very short. 0.1. What is the ratio of the Aid flow (current US$) of Malawi in 1982 to that in 2001?
Your answer should be compact. 0.19. What is the ratio of the Aid flow (current US$) in Timor-Leste in 1982 to that in 2001?
Offer a terse response. 0.06. What is the ratio of the Aid flow (current US$) in Pacific island small states in 1982 to that in 2002?
Give a very brief answer. 136. What is the ratio of the Aid flow (current US$) in Guinea in 1982 to that in 2002?
Keep it short and to the point. 0.06. What is the ratio of the Aid flow (current US$) in Malawi in 1982 to that in 2002?
Offer a very short reply. 0.15. What is the ratio of the Aid flow (current US$) of Timor-Leste in 1982 to that in 2002?
Give a very brief answer. 0.26. What is the ratio of the Aid flow (current US$) of Pacific island small states in 1982 to that in 2003?
Your answer should be very brief. 7.56. What is the ratio of the Aid flow (current US$) of Guinea in 1982 to that in 2003?
Your answer should be very brief. 0.05. What is the ratio of the Aid flow (current US$) of Malawi in 1982 to that in 2003?
Your answer should be very brief. 0.34. What is the ratio of the Aid flow (current US$) of Timor-Leste in 1982 to that in 2003?
Your response must be concise. 0.24. What is the ratio of the Aid flow (current US$) of Guinea in 1982 to that in 2004?
Make the answer very short. 0.07. What is the ratio of the Aid flow (current US$) in Malawi in 1982 to that in 2004?
Keep it short and to the point. 0.16. What is the ratio of the Aid flow (current US$) of Timor-Leste in 1982 to that in 2004?
Offer a terse response. 0.11. What is the ratio of the Aid flow (current US$) of Pacific island small states in 1982 to that in 2005?
Your response must be concise. 0.28. What is the ratio of the Aid flow (current US$) in Guinea in 1982 to that in 2005?
Make the answer very short. 0.23. What is the ratio of the Aid flow (current US$) of Malawi in 1982 to that in 2005?
Your answer should be very brief. 0.13. What is the ratio of the Aid flow (current US$) in Timor-Leste in 1982 to that in 2005?
Give a very brief answer. 0.13. What is the ratio of the Aid flow (current US$) of Pacific island small states in 2001 to that in 2002?
Your answer should be compact. 18. What is the ratio of the Aid flow (current US$) in Guinea in 2001 to that in 2002?
Give a very brief answer. 0.57. What is the ratio of the Aid flow (current US$) in Malawi in 2001 to that in 2002?
Your response must be concise. 0.78. What is the ratio of the Aid flow (current US$) in Timor-Leste in 2001 to that in 2002?
Make the answer very short. 4.6. What is the ratio of the Aid flow (current US$) of Guinea in 2001 to that in 2003?
Provide a succinct answer. 0.54. What is the ratio of the Aid flow (current US$) of Malawi in 2001 to that in 2003?
Keep it short and to the point. 1.78. What is the ratio of the Aid flow (current US$) in Timor-Leste in 2001 to that in 2003?
Offer a terse response. 4.23. What is the ratio of the Aid flow (current US$) in Guinea in 2001 to that in 2004?
Your response must be concise. 0.71. What is the ratio of the Aid flow (current US$) of Malawi in 2001 to that in 2004?
Offer a terse response. 0.83. What is the ratio of the Aid flow (current US$) in Timor-Leste in 2001 to that in 2004?
Your answer should be very brief. 1.87. What is the ratio of the Aid flow (current US$) of Pacific island small states in 2001 to that in 2005?
Your answer should be very brief. 0.04. What is the ratio of the Aid flow (current US$) in Guinea in 2001 to that in 2005?
Make the answer very short. 2.4. What is the ratio of the Aid flow (current US$) of Malawi in 2001 to that in 2005?
Give a very brief answer. 0.67. What is the ratio of the Aid flow (current US$) of Timor-Leste in 2001 to that in 2005?
Provide a succinct answer. 2.34. What is the ratio of the Aid flow (current US$) in Pacific island small states in 2002 to that in 2003?
Provide a succinct answer. 0.06. What is the ratio of the Aid flow (current US$) in Guinea in 2002 to that in 2003?
Make the answer very short. 0.95. What is the ratio of the Aid flow (current US$) in Malawi in 2002 to that in 2003?
Give a very brief answer. 2.3. What is the ratio of the Aid flow (current US$) in Timor-Leste in 2002 to that in 2003?
Your answer should be compact. 0.92. What is the ratio of the Aid flow (current US$) of Guinea in 2002 to that in 2004?
Make the answer very short. 1.24. What is the ratio of the Aid flow (current US$) of Malawi in 2002 to that in 2004?
Offer a very short reply. 1.07. What is the ratio of the Aid flow (current US$) of Timor-Leste in 2002 to that in 2004?
Offer a terse response. 0.41. What is the ratio of the Aid flow (current US$) of Pacific island small states in 2002 to that in 2005?
Provide a succinct answer. 0. What is the ratio of the Aid flow (current US$) of Guinea in 2002 to that in 2005?
Keep it short and to the point. 4.2. What is the ratio of the Aid flow (current US$) of Malawi in 2002 to that in 2005?
Give a very brief answer. 0.87. What is the ratio of the Aid flow (current US$) in Timor-Leste in 2002 to that in 2005?
Offer a very short reply. 0.51. What is the ratio of the Aid flow (current US$) in Guinea in 2003 to that in 2004?
Your answer should be very brief. 1.3. What is the ratio of the Aid flow (current US$) in Malawi in 2003 to that in 2004?
Provide a short and direct response. 0.47. What is the ratio of the Aid flow (current US$) in Timor-Leste in 2003 to that in 2004?
Make the answer very short. 0.44. What is the ratio of the Aid flow (current US$) of Pacific island small states in 2003 to that in 2005?
Offer a very short reply. 0.04. What is the ratio of the Aid flow (current US$) in Guinea in 2003 to that in 2005?
Make the answer very short. 4.42. What is the ratio of the Aid flow (current US$) in Malawi in 2003 to that in 2005?
Make the answer very short. 0.38. What is the ratio of the Aid flow (current US$) of Timor-Leste in 2003 to that in 2005?
Your response must be concise. 0.55. What is the ratio of the Aid flow (current US$) of Guinea in 2004 to that in 2005?
Offer a very short reply. 3.4. What is the ratio of the Aid flow (current US$) in Malawi in 2004 to that in 2005?
Provide a short and direct response. 0.81. What is the ratio of the Aid flow (current US$) in Timor-Leste in 2004 to that in 2005?
Offer a very short reply. 1.25. What is the difference between the highest and the second highest Aid flow (current US$) in Pacific island small states?
Make the answer very short. 3.25e+06. What is the difference between the highest and the second highest Aid flow (current US$) in Malawi?
Provide a short and direct response. 2.55e+06. What is the difference between the highest and the second highest Aid flow (current US$) in Timor-Leste?
Your answer should be very brief. 1.22e+06. What is the difference between the highest and the lowest Aid flow (current US$) of Pacific island small states?
Provide a succinct answer. 4.82e+06. What is the difference between the highest and the lowest Aid flow (current US$) in Guinea?
Make the answer very short. 4.13e+06. What is the difference between the highest and the lowest Aid flow (current US$) of Malawi?
Your answer should be very brief. 1.69e+07. What is the difference between the highest and the lowest Aid flow (current US$) in Timor-Leste?
Offer a terse response. 2.47e+06. 